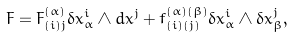Convert formula to latex. <formula><loc_0><loc_0><loc_500><loc_500>F = F ^ { ( \alpha ) } _ { ( i ) j } \delta x ^ { i } _ { \alpha } \wedge d x ^ { j } + f ^ { ( \alpha ) ( \beta ) } _ { ( i ) ( j ) } \delta x ^ { i } _ { \alpha } \wedge \delta x ^ { j } _ { \beta } ,</formula> 